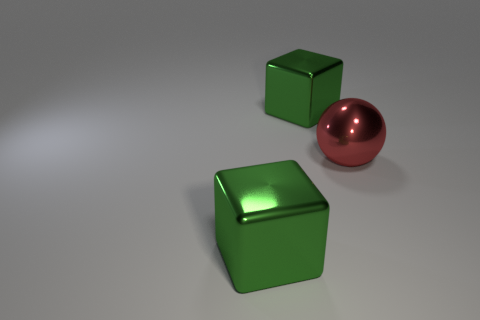Add 2 purple rubber balls. How many objects exist? 5 Subtract all balls. How many objects are left? 2 Add 3 big cubes. How many big cubes are left? 5 Add 3 tiny metallic cubes. How many tiny metallic cubes exist? 3 Subtract 0 red cubes. How many objects are left? 3 Subtract all green objects. Subtract all metal spheres. How many objects are left? 0 